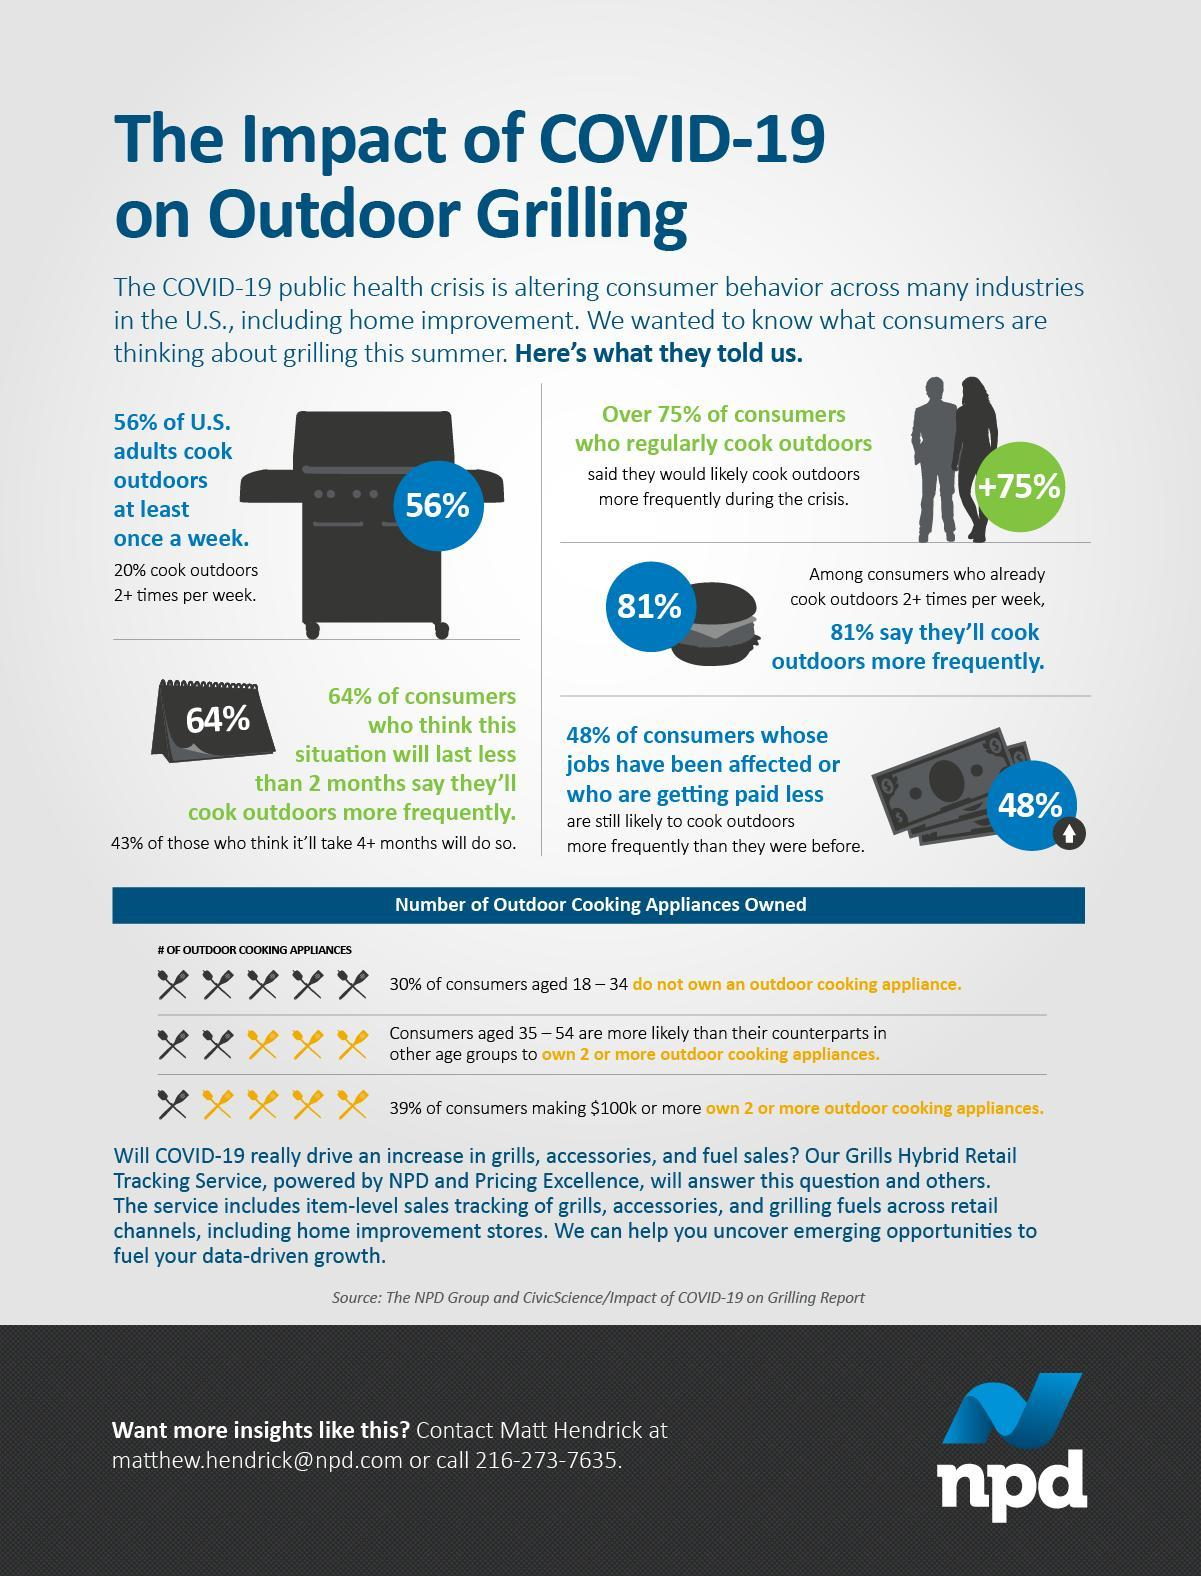In total how many pairs of spoons and forks are shown?
Answer the question with a short phrase. 15 How many pairs of yellow spoons and forks are shown? 7 